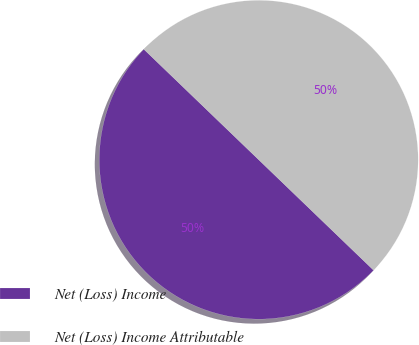<chart> <loc_0><loc_0><loc_500><loc_500><pie_chart><fcel>Net (Loss) Income<fcel>Net (Loss) Income Attributable<nl><fcel>50.0%<fcel>50.0%<nl></chart> 